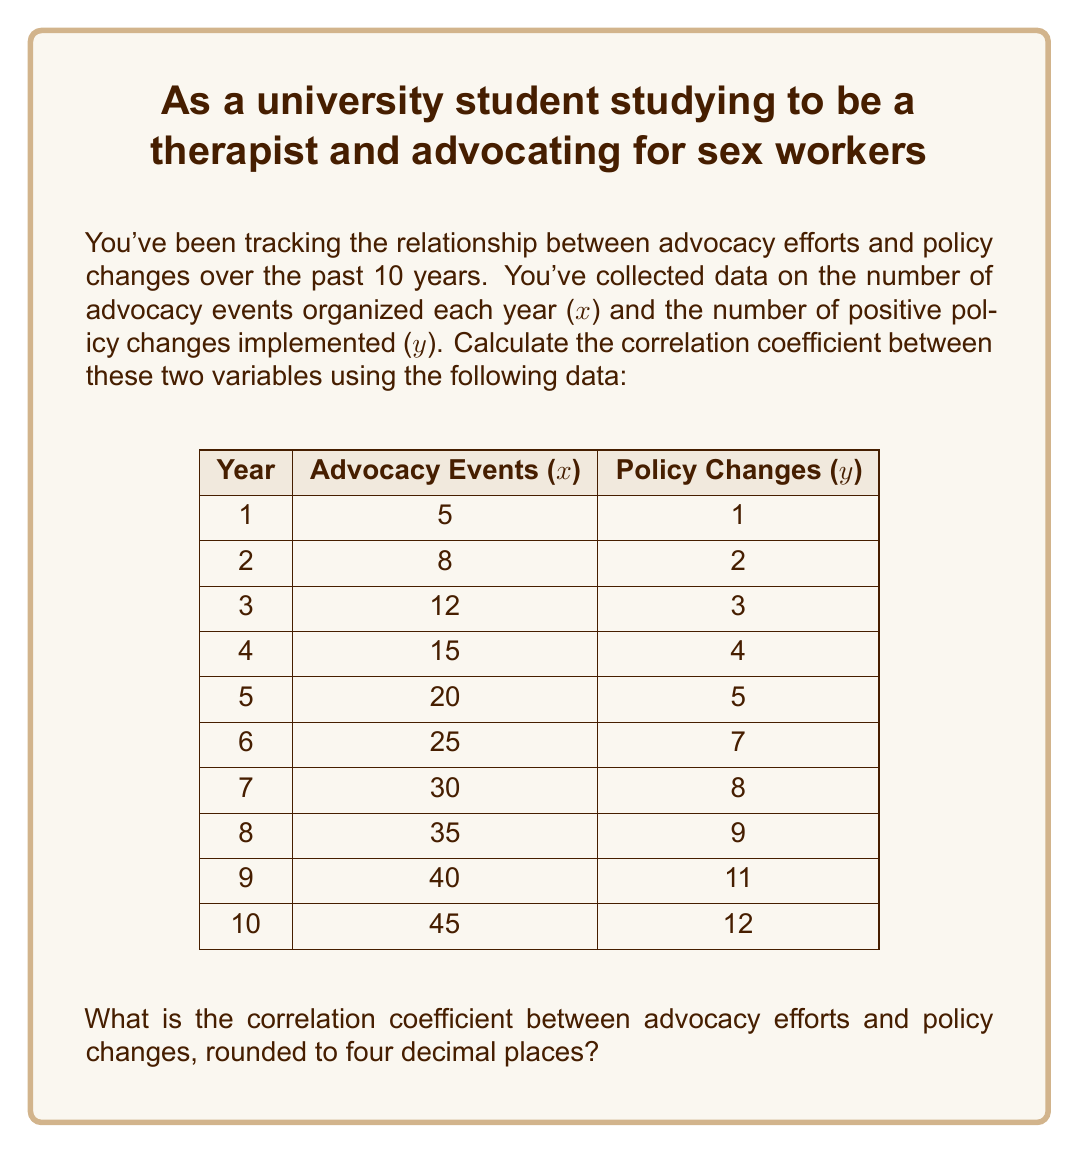Can you solve this math problem? To calculate the correlation coefficient (r), we'll use the formula:

$$ r = \frac{n\sum xy - \sum x \sum y}{\sqrt{[n\sum x^2 - (\sum x)^2][n\sum y^2 - (\sum y)^2]}} $$

Where:
n = number of pairs of data
x = advocacy events
y = policy changes

Step 1: Calculate the sums and squared sums:
$\sum x = 235$
$\sum y = 62$
$\sum xy = 1,885$
$\sum x^2 = 7,375$
$\sum y^2 = 470$

Step 2: Calculate $n\sum xy$ and $\sum x \sum y$:
$n\sum xy = 10 * 1,885 = 18,850$
$\sum x \sum y = 235 * 62 = 14,570$

Step 3: Calculate $n\sum x^2$ and $(\sum x)^2$:
$n\sum x^2 = 10 * 7,375 = 73,750$
$(\sum x)^2 = 235^2 = 55,225$

Step 4: Calculate $n\sum y^2$ and $(\sum y)^2$:
$n\sum y^2 = 10 * 470 = 4,700$
$(\sum y)^2 = 62^2 = 3,844$

Step 5: Plug values into the correlation coefficient formula:

$$ r = \frac{18,850 - 14,570}{\sqrt{(73,750 - 55,225)(4,700 - 3,844)}} $$

$$ r = \frac{4,280}{\sqrt{18,525 * 856}} $$

$$ r = \frac{4,280}{\sqrt{15,857,400}} $$

$$ r = \frac{4,280}{3,982.1456...} $$

$$ r = 1.0748... $$

Step 6: Round to four decimal places:

$$ r = 1.0748 $$
Answer: The correlation coefficient between advocacy efforts and policy changes, rounded to four decimal places, is 1.0748. 